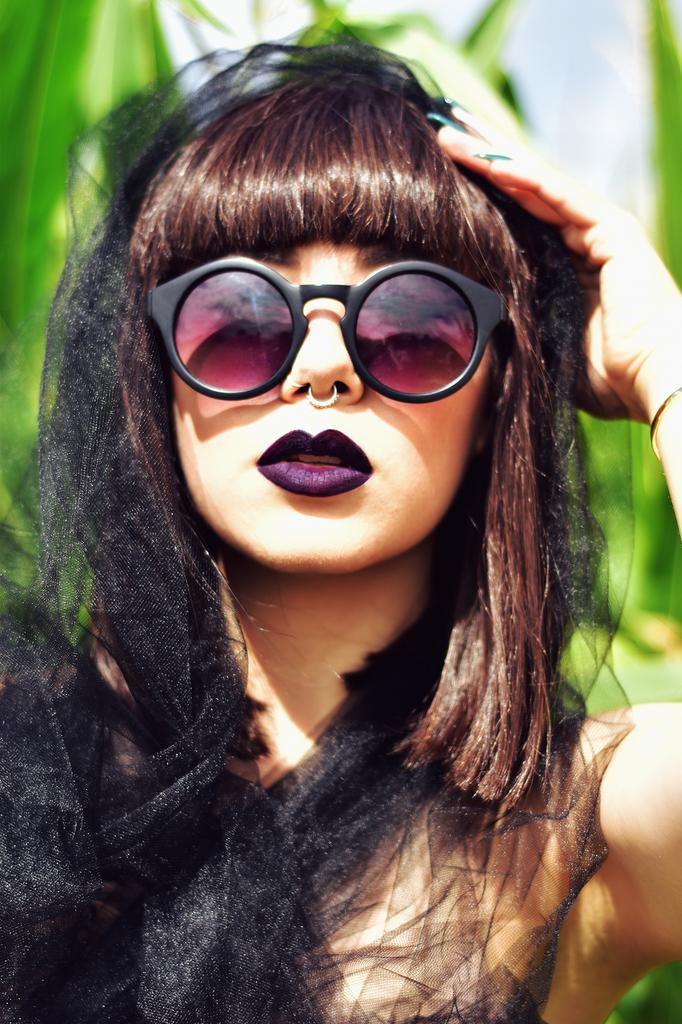Who is the main subject in the image? There is a girl in the image. Where is the girl located in the image? The girl is in the center of the image. What accessory is the girl wearing? The girl is wearing glasses. What type of cakes is the girl creating in the image? There is no indication in the image that the girl is creating any cakes. 